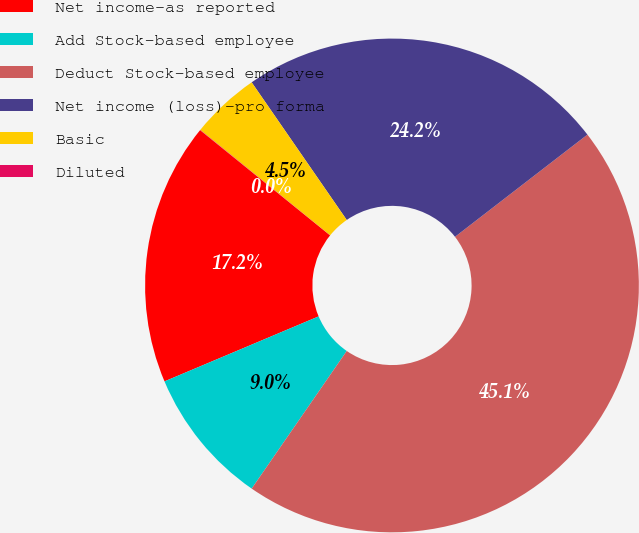<chart> <loc_0><loc_0><loc_500><loc_500><pie_chart><fcel>Net income-as reported<fcel>Add Stock-based employee<fcel>Deduct Stock-based employee<fcel>Net income (loss)-pro forma<fcel>Basic<fcel>Diluted<nl><fcel>17.18%<fcel>9.03%<fcel>45.08%<fcel>24.16%<fcel>4.53%<fcel>0.02%<nl></chart> 